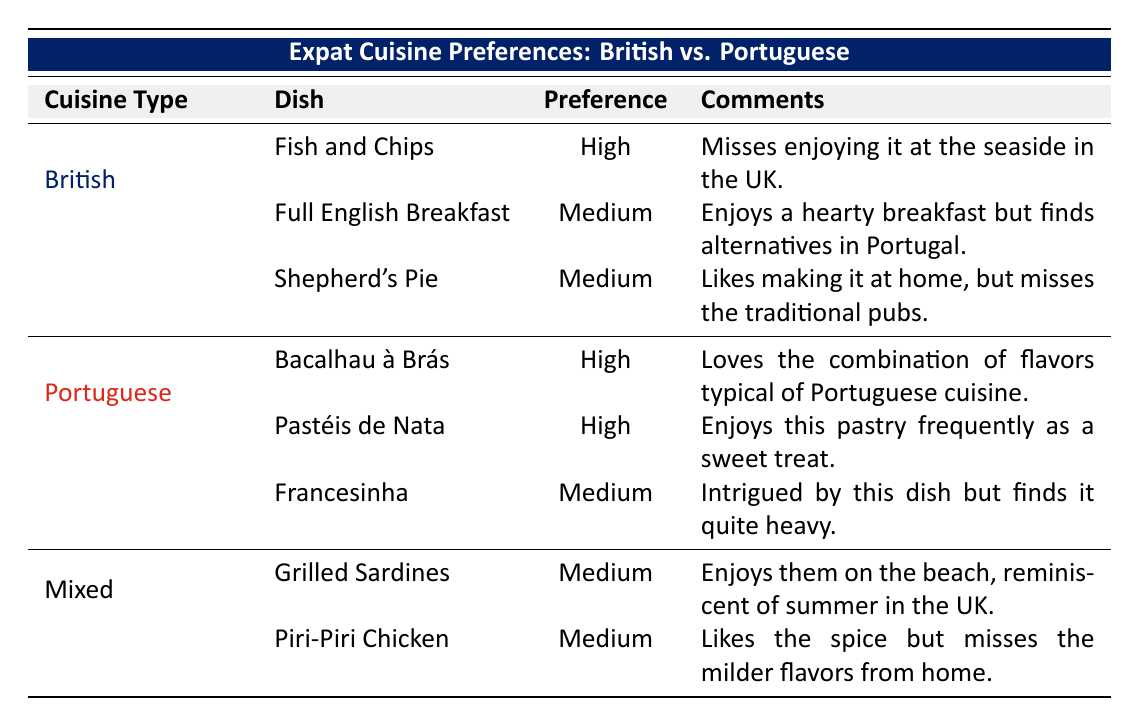What British dish has the highest preference level? The table shows that "Fish and Chips" has a "High" preference level under British cuisine, while the other British dishes have a "Medium" preference level.
Answer: Fish and Chips Which Portuguese dish has a "High" preference level? The table lists "Bacalhau à Brás" and "Pastéis de Nata" both having a "High" preference level, indicating a strong liking for these dishes within Portuguese cuisine.
Answer: Bacalhau à Brás, Pastéis de Nata How many dishes are listed under Portuguese cuisine? The table indicates there are three dishes listed under Portuguese cuisine: "Bacalhau à Brás," "Pastéis de Nata," and "Francesinha." The total count can be directly observed from the table.
Answer: 3 Do expats prefer British or Portuguese cuisine more? Looking at the preference levels, there are two high preferences for Portuguese cuisine (Bacalhau à Brás and Pastéis de Nata) and one high preference for British cuisine (Fish and Chips). Therefore, Portuguese cuisine appears to be more preferred according to the table.
Answer: Portuguese cuisine What is the preference level for "Piri-Piri Chicken"? According to the table, "Piri-Piri Chicken" is listed under Mixed cuisine, with a preference level of "Medium." This can be found directly by looking at the associated row in the table.
Answer: Medium If we consider the comments about the dishes, which British dish misses a specific experience? The comments for "Fish and Chips" mention missing the enjoyment of it at the seaside in the UK, indicating that this dish is associated with a specific experience that the expat misses.
Answer: Fish and Chips Which dish is mentioned as heavy under Portuguese offerings? The table notes that "Francesinha" is perceived as quite heavy by the expat, which can be easily identified in the comments section of the Portuguese dishes.
Answer: Francesinha What is the combination of medium preference levels for British dishes? There are two British dishes with "Medium" preference levels: "Full English Breakfast" and "Shepherd's Pie." Therefore, the total number of "Medium" preferences for British cuisine can be summed.
Answer: 2 How many dishes have "Medium" preference levels overall? The table lists a total of four dishes with a "Medium" preference level: "Full English Breakfast," "Shepherd's Pie," "Francesinha," and "Grilled Sardines." The total can be calculated by direct observation of these dishes.
Answer: 4 